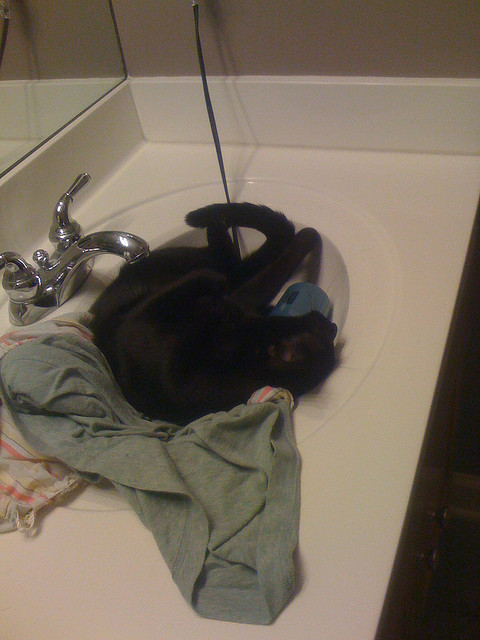What color is the cat in the sink? The cat lounging in the sink is black. 